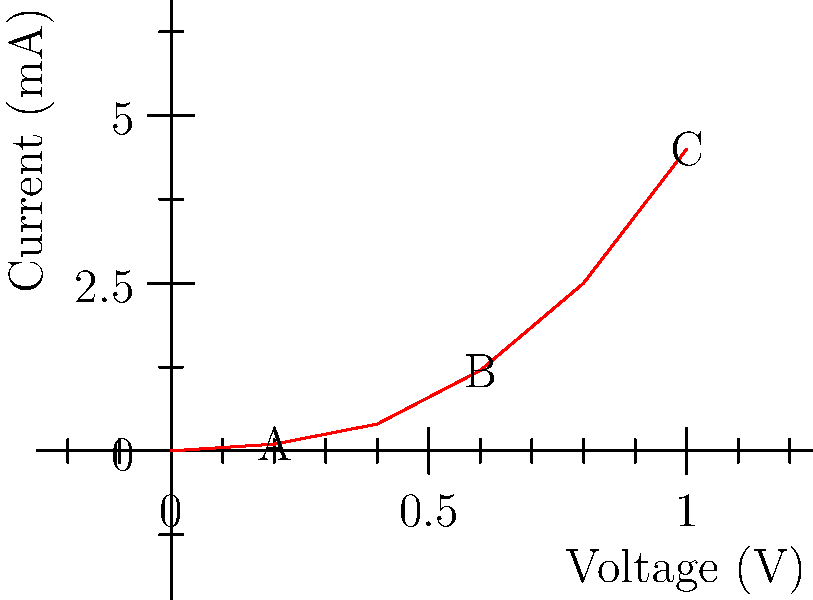Analyze the voltage-current characteristic curve of a semiconductor device used in robot circuitry. Calculate the dynamic resistance of the device at point B if the voltage at point A is 0.2V and the voltage at point C is 1.0V. To solve this problem, we need to follow these steps:

1. Understand dynamic resistance: It's the reciprocal of the slope of the V-I curve at a given point.

2. Identify the coordinates of points A, B, and C:
   A: (0.2V, 0.1mA)
   B: (0.6V, 1.2mA)
   C: (1.0V, 4.5mA)

3. Calculate the slope between points A and C:
   Slope = $\frac{\Delta I}{\Delta V} = \frac{I_C - I_A}{V_C - V_A} = \frac{4.5mA - 0.1mA}{1.0V - 0.2V} = \frac{4.4mA}{0.8V} = 5.5 \frac{mA}{V}$

4. The dynamic resistance is the reciprocal of this slope:
   $R_{dynamic} = \frac{1}{slope} = \frac{1}{5.5 \frac{mA}{V}} = 0.1818 \frac{V}{mA} = 181.8 \Omega$

5. Convert to standard units:
   $181.8 \Omega = 0.1818 k\Omega$

Therefore, the dynamic resistance at point B is approximately 0.1818 kΩ.
Answer: 0.1818 kΩ 